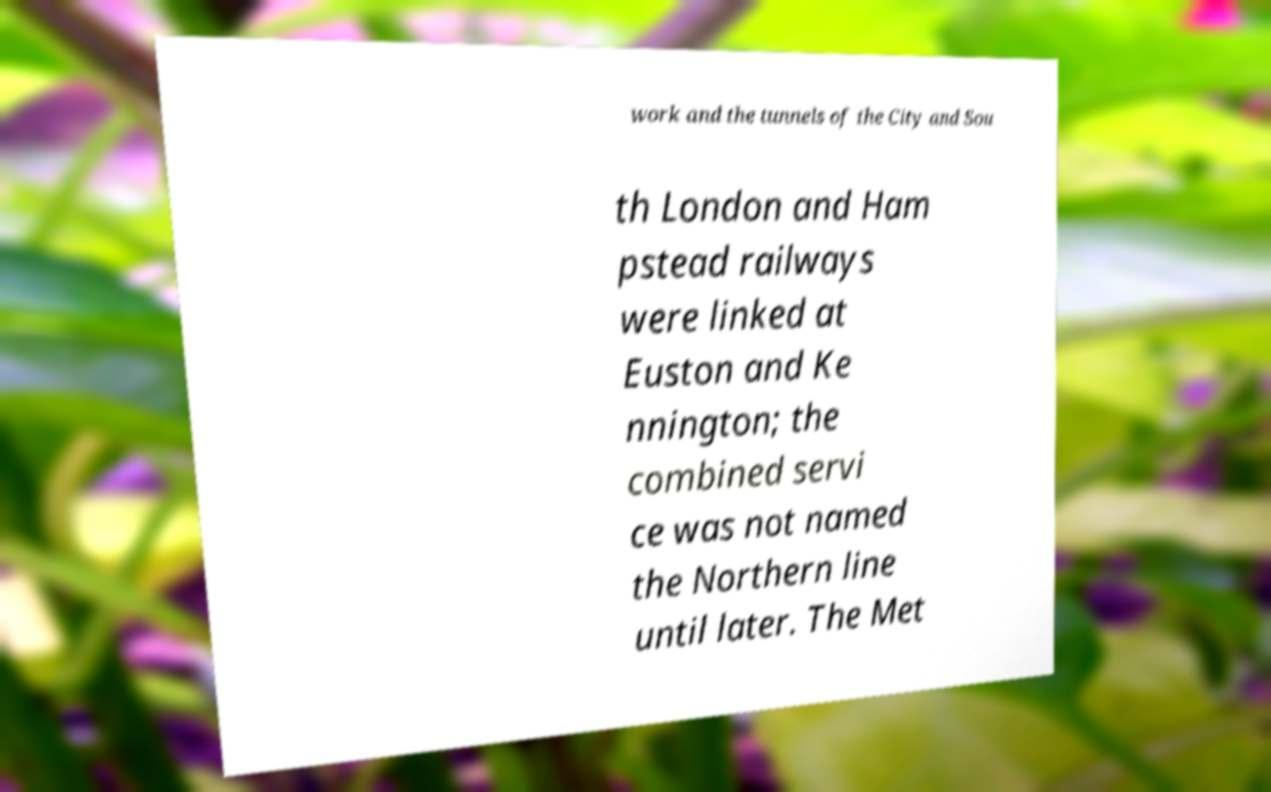For documentation purposes, I need the text within this image transcribed. Could you provide that? work and the tunnels of the City and Sou th London and Ham pstead railways were linked at Euston and Ke nnington; the combined servi ce was not named the Northern line until later. The Met 